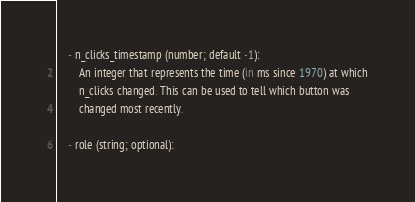<code> <loc_0><loc_0><loc_500><loc_500><_Python_>    - n_clicks_timestamp (number; default -1):
        An integer that represents the time (in ms since 1970) at which
        n_clicks changed. This can be used to tell which button was
        changed most recently.

    - role (string; optional):</code> 